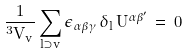Convert formula to latex. <formula><loc_0><loc_0><loc_500><loc_500>\frac { 1 } { ^ { 3 } V _ { v } } \sum _ { l \supset v } \epsilon _ { \alpha \beta \gamma } \, \delta _ { l } \, U ^ { \alpha \beta ^ { \prime } } \, = \, 0</formula> 